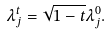Convert formula to latex. <formula><loc_0><loc_0><loc_500><loc_500>\lambda _ { j } ^ { t } = \sqrt { 1 - t } \lambda _ { j } ^ { 0 } .</formula> 